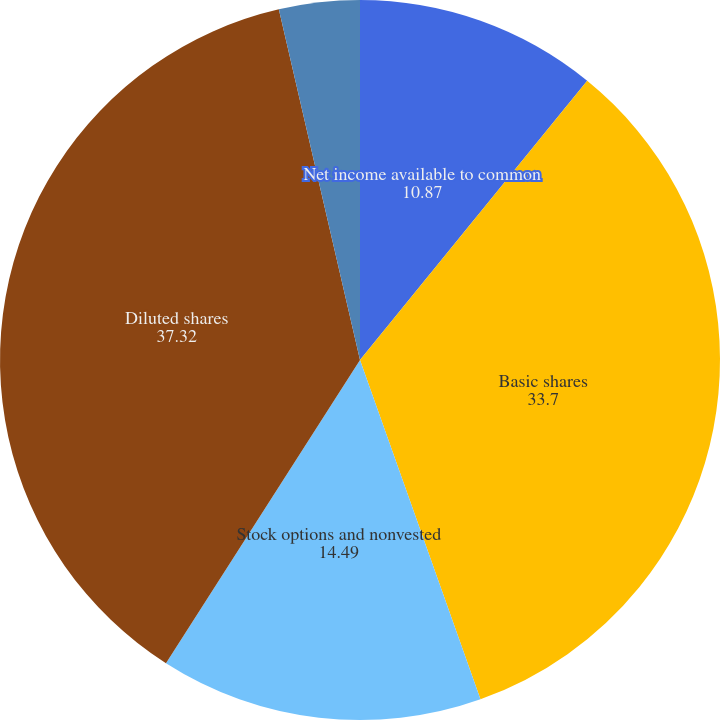Convert chart to OTSL. <chart><loc_0><loc_0><loc_500><loc_500><pie_chart><fcel>Net income available to common<fcel>Basic shares<fcel>Stock options and nonvested<fcel>Diluted shares<fcel>Basic earnings per share<fcel>Diluted earnings per share<nl><fcel>10.87%<fcel>33.7%<fcel>14.49%<fcel>37.32%<fcel>3.62%<fcel>0.0%<nl></chart> 